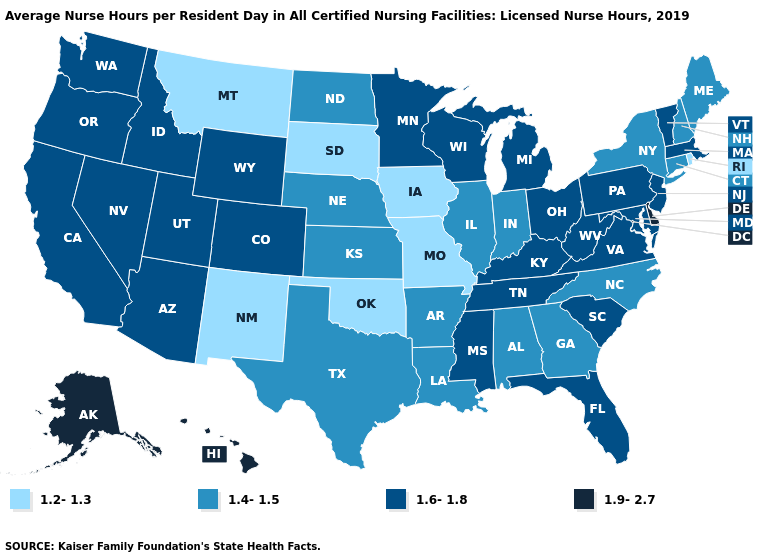What is the value of Montana?
Concise answer only. 1.2-1.3. Does Arkansas have the highest value in the South?
Concise answer only. No. Does Tennessee have the lowest value in the USA?
Short answer required. No. What is the value of Delaware?
Be succinct. 1.9-2.7. Does Rhode Island have the lowest value in the Northeast?
Quick response, please. Yes. Which states have the lowest value in the USA?
Quick response, please. Iowa, Missouri, Montana, New Mexico, Oklahoma, Rhode Island, South Dakota. Name the states that have a value in the range 1.6-1.8?
Give a very brief answer. Arizona, California, Colorado, Florida, Idaho, Kentucky, Maryland, Massachusetts, Michigan, Minnesota, Mississippi, Nevada, New Jersey, Ohio, Oregon, Pennsylvania, South Carolina, Tennessee, Utah, Vermont, Virginia, Washington, West Virginia, Wisconsin, Wyoming. Which states have the lowest value in the USA?
Answer briefly. Iowa, Missouri, Montana, New Mexico, Oklahoma, Rhode Island, South Dakota. Name the states that have a value in the range 1.2-1.3?
Write a very short answer. Iowa, Missouri, Montana, New Mexico, Oklahoma, Rhode Island, South Dakota. What is the value of Wisconsin?
Keep it brief. 1.6-1.8. Does Delaware have the highest value in the USA?
Concise answer only. Yes. Is the legend a continuous bar?
Short answer required. No. Which states have the lowest value in the MidWest?
Concise answer only. Iowa, Missouri, South Dakota. Name the states that have a value in the range 1.9-2.7?
Short answer required. Alaska, Delaware, Hawaii. Does Alaska have a lower value than Kansas?
Give a very brief answer. No. 